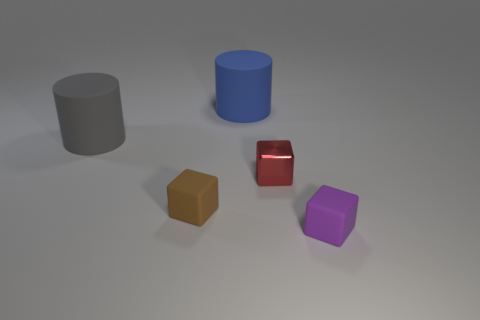Subtract all small rubber blocks. How many blocks are left? 1 Add 2 tiny cubes. How many objects exist? 7 Subtract all brown cubes. How many cubes are left? 2 Subtract all cylinders. How many objects are left? 3 Subtract 1 cubes. How many cubes are left? 2 Subtract all green cubes. How many blue cylinders are left? 1 Add 2 large gray things. How many large gray things are left? 3 Add 3 tiny red cubes. How many tiny red cubes exist? 4 Subtract 0 purple spheres. How many objects are left? 5 Subtract all cyan blocks. Subtract all purple spheres. How many blocks are left? 3 